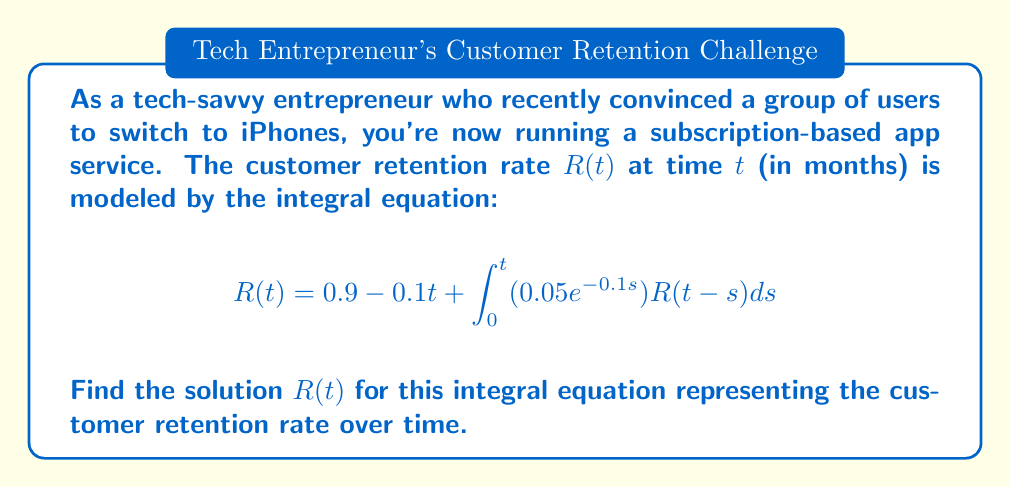Give your solution to this math problem. To solve this integral equation, we'll use the Laplace transform method:

1) Take the Laplace transform of both sides:
   $$\mathcal{L}\{R(t)\} = \mathcal{L}\{0.9 - 0.1t\} + \mathcal{L}\{\int_0^t (0.05e^{-0.1s})R(t-s)ds\}$$

2) Let $\mathcal{L}\{R(t)\} = \bar{R}(s)$. Using Laplace transform properties:
   $$\bar{R}(s) = \frac{0.9}{s} - \frac{0.1}{s^2} + 0.05\bar{R}(s)\mathcal{L}\{e^{-0.1t}\}$$

3) Simplify:
   $$\bar{R}(s) = \frac{0.9}{s} - \frac{0.1}{s^2} + \frac{0.05\bar{R}(s)}{s+0.1}$$

4) Solve for $\bar{R}(s)$:
   $$\bar{R}(s)(1 - \frac{0.05}{s+0.1}) = \frac{0.9}{s} - \frac{0.1}{s^2}$$
   $$\bar{R}(s) = \frac{0.9s - 0.1}{s^2(s+0.1 - 0.05)} = \frac{0.9s - 0.1}{s^2(s+0.05)}$$

5) Partial fraction decomposition:
   $$\bar{R}(s) = \frac{A}{s} + \frac{B}{s^2} + \frac{C}{s+0.05}$$
   
   Solving for A, B, and C:
   $$A = 0.9, B = -18, C = -0.9$$

6) Take the inverse Laplace transform:
   $$R(t) = 0.9 - 18t - 0.9e^{-0.05t}$$

This is the solution to the integral equation.
Answer: $R(t) = 0.9 - 18t - 0.9e^{-0.05t}$ 